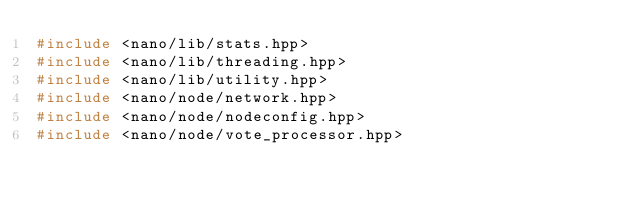<code> <loc_0><loc_0><loc_500><loc_500><_C++_>#include <nano/lib/stats.hpp>
#include <nano/lib/threading.hpp>
#include <nano/lib/utility.hpp>
#include <nano/node/network.hpp>
#include <nano/node/nodeconfig.hpp>
#include <nano/node/vote_processor.hpp></code> 